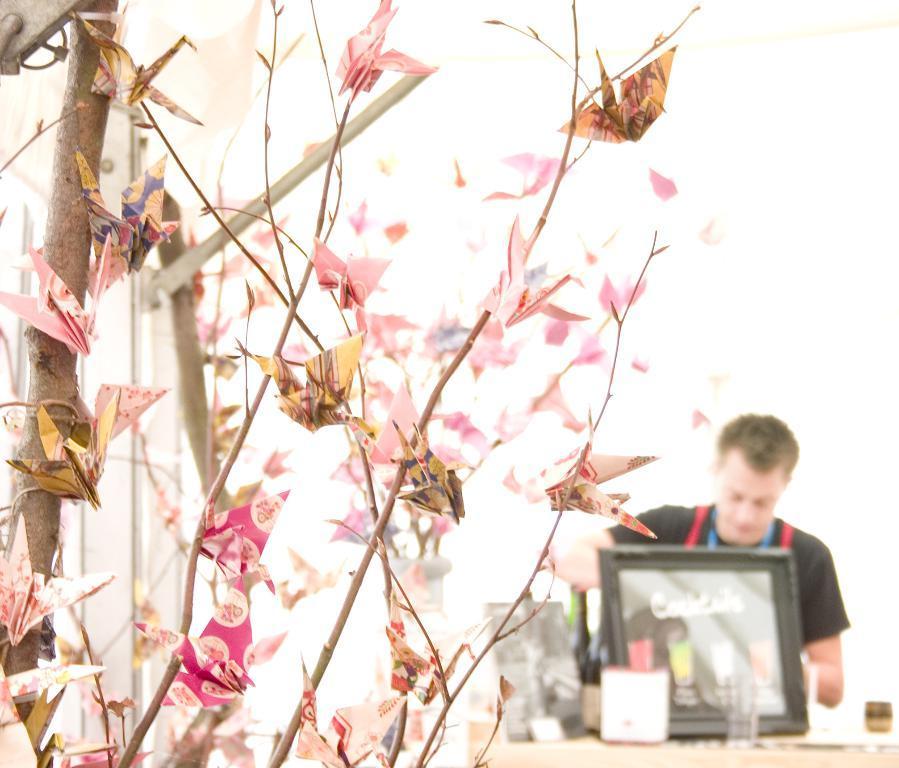Describe this image in one or two sentences. In this image we can see a person sitting beside the table containing a photo frame, bottle and some objects on it. On the left side we can see some paper art on the branches of a tree. 